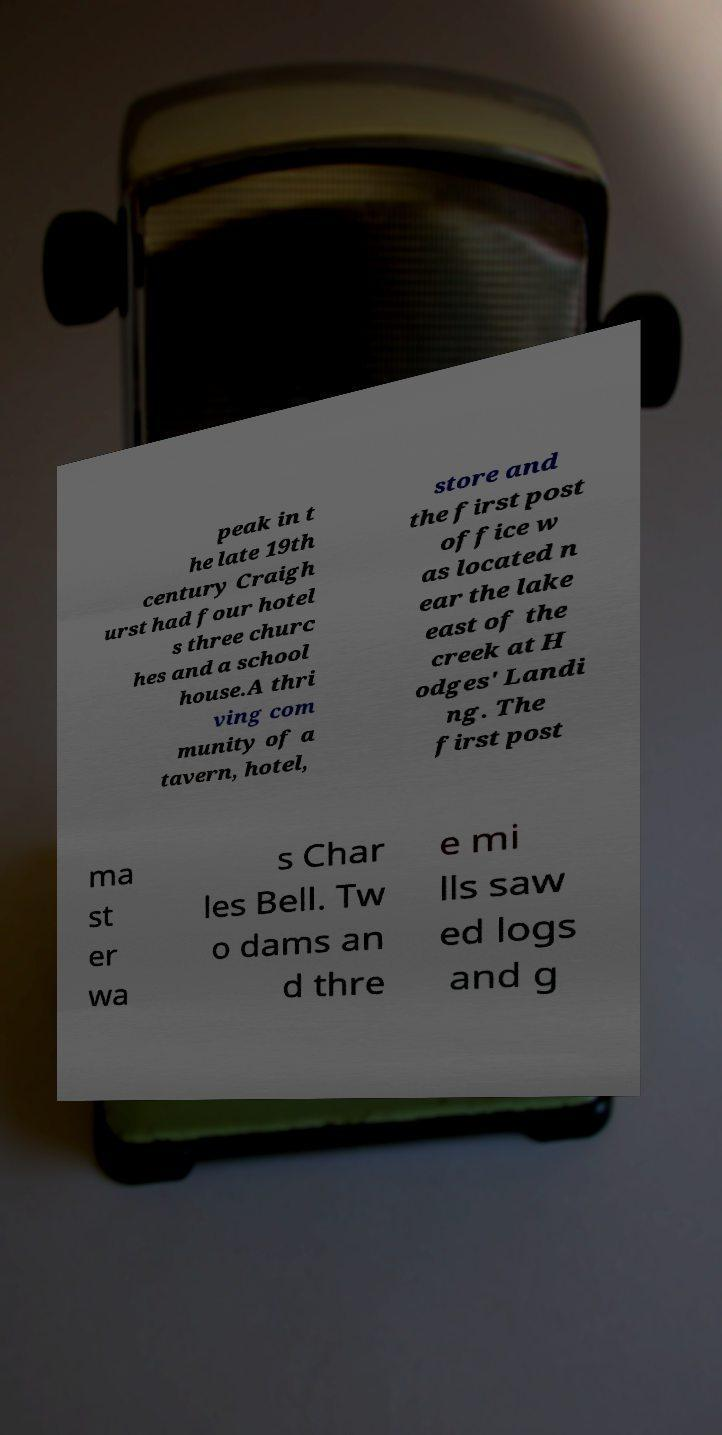Could you extract and type out the text from this image? peak in t he late 19th century Craigh urst had four hotel s three churc hes and a school house.A thri ving com munity of a tavern, hotel, store and the first post office w as located n ear the lake east of the creek at H odges' Landi ng. The first post ma st er wa s Char les Bell. Tw o dams an d thre e mi lls saw ed logs and g 